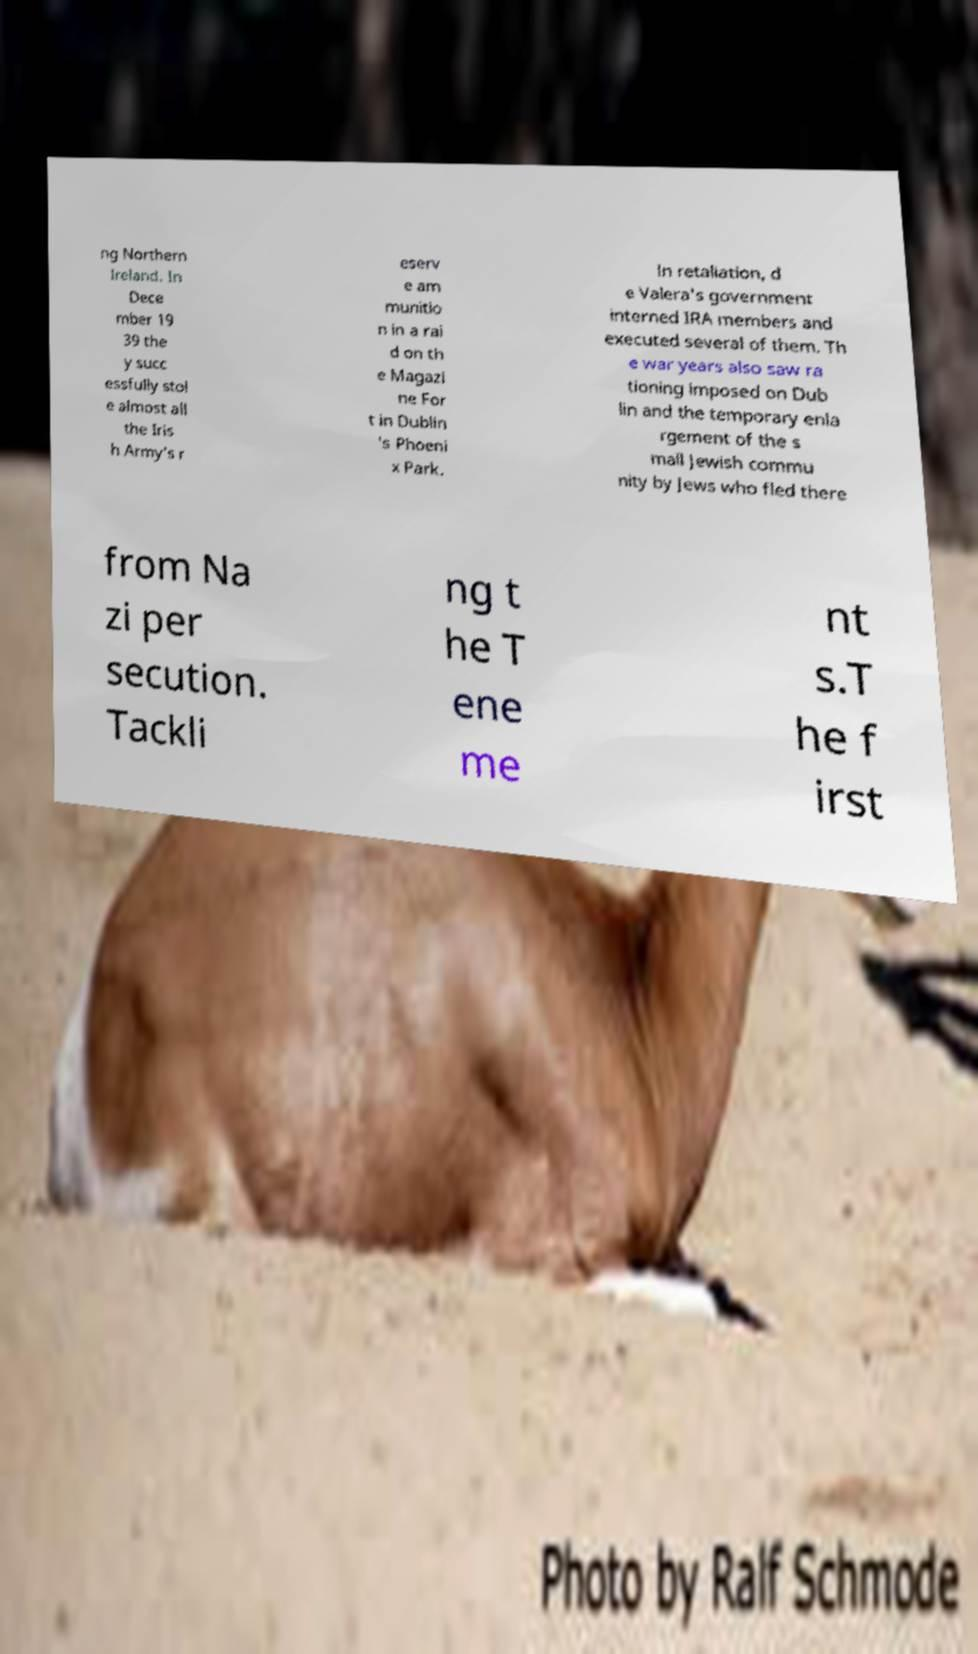Can you accurately transcribe the text from the provided image for me? ng Northern Ireland. In Dece mber 19 39 the y succ essfully stol e almost all the Iris h Army's r eserv e am munitio n in a rai d on th e Magazi ne For t in Dublin 's Phoeni x Park. In retaliation, d e Valera's government interned IRA members and executed several of them. Th e war years also saw ra tioning imposed on Dub lin and the temporary enla rgement of the s mall Jewish commu nity by Jews who fled there from Na zi per secution. Tackli ng t he T ene me nt s.T he f irst 